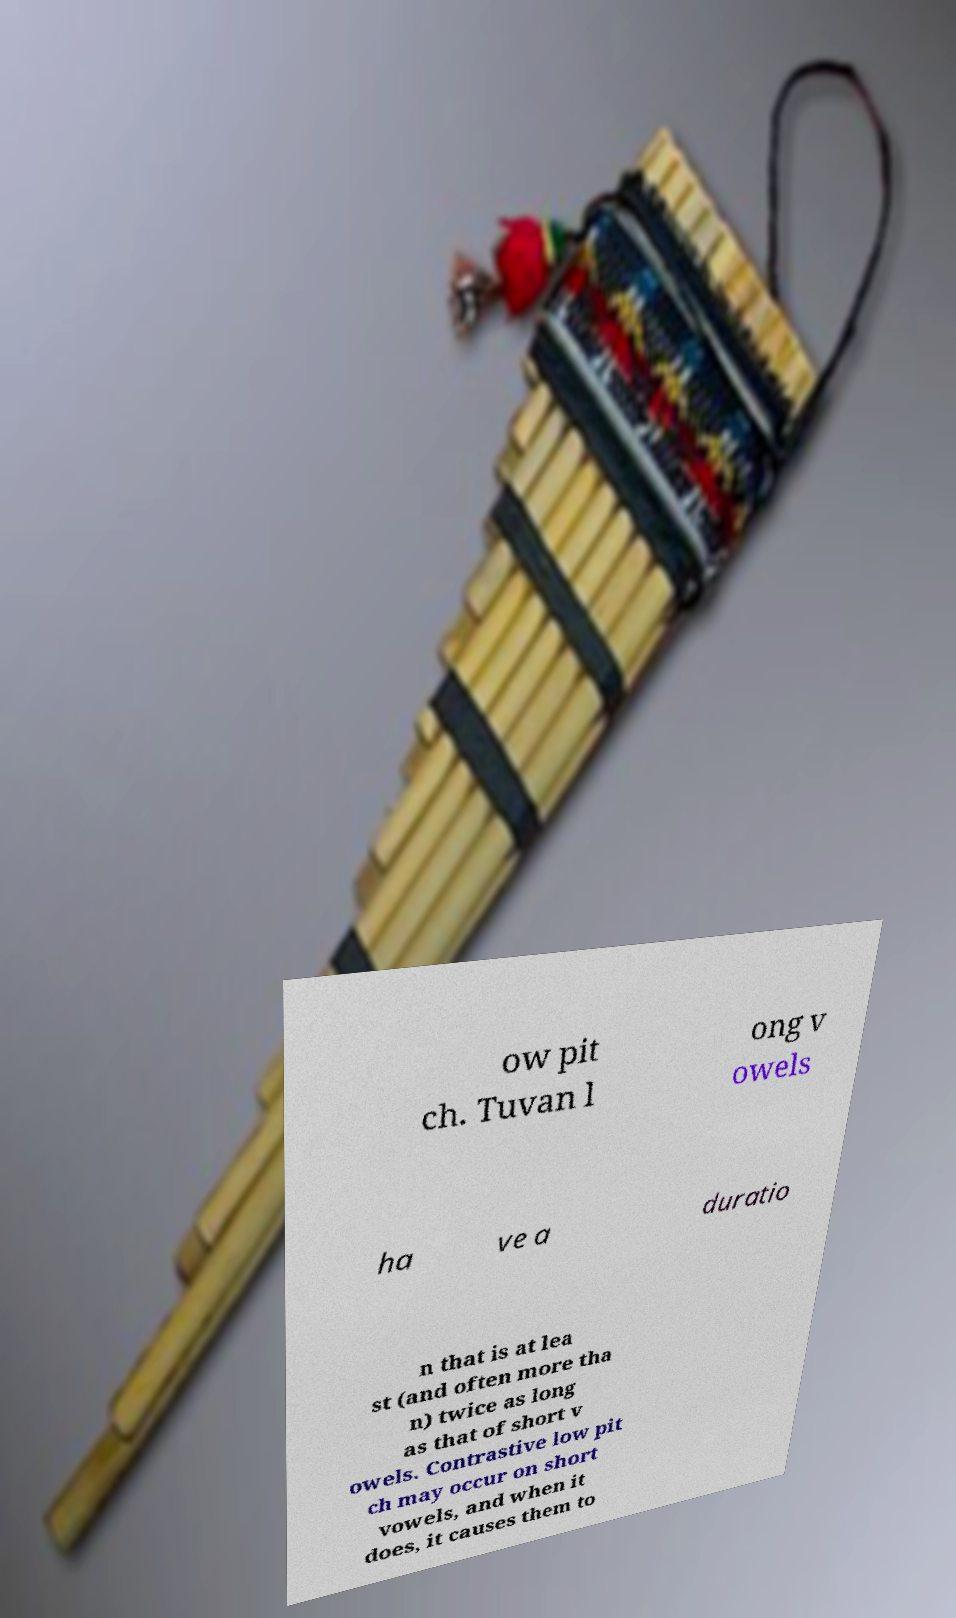Please read and relay the text visible in this image. What does it say? ow pit ch. Tuvan l ong v owels ha ve a duratio n that is at lea st (and often more tha n) twice as long as that of short v owels. Contrastive low pit ch may occur on short vowels, and when it does, it causes them to 